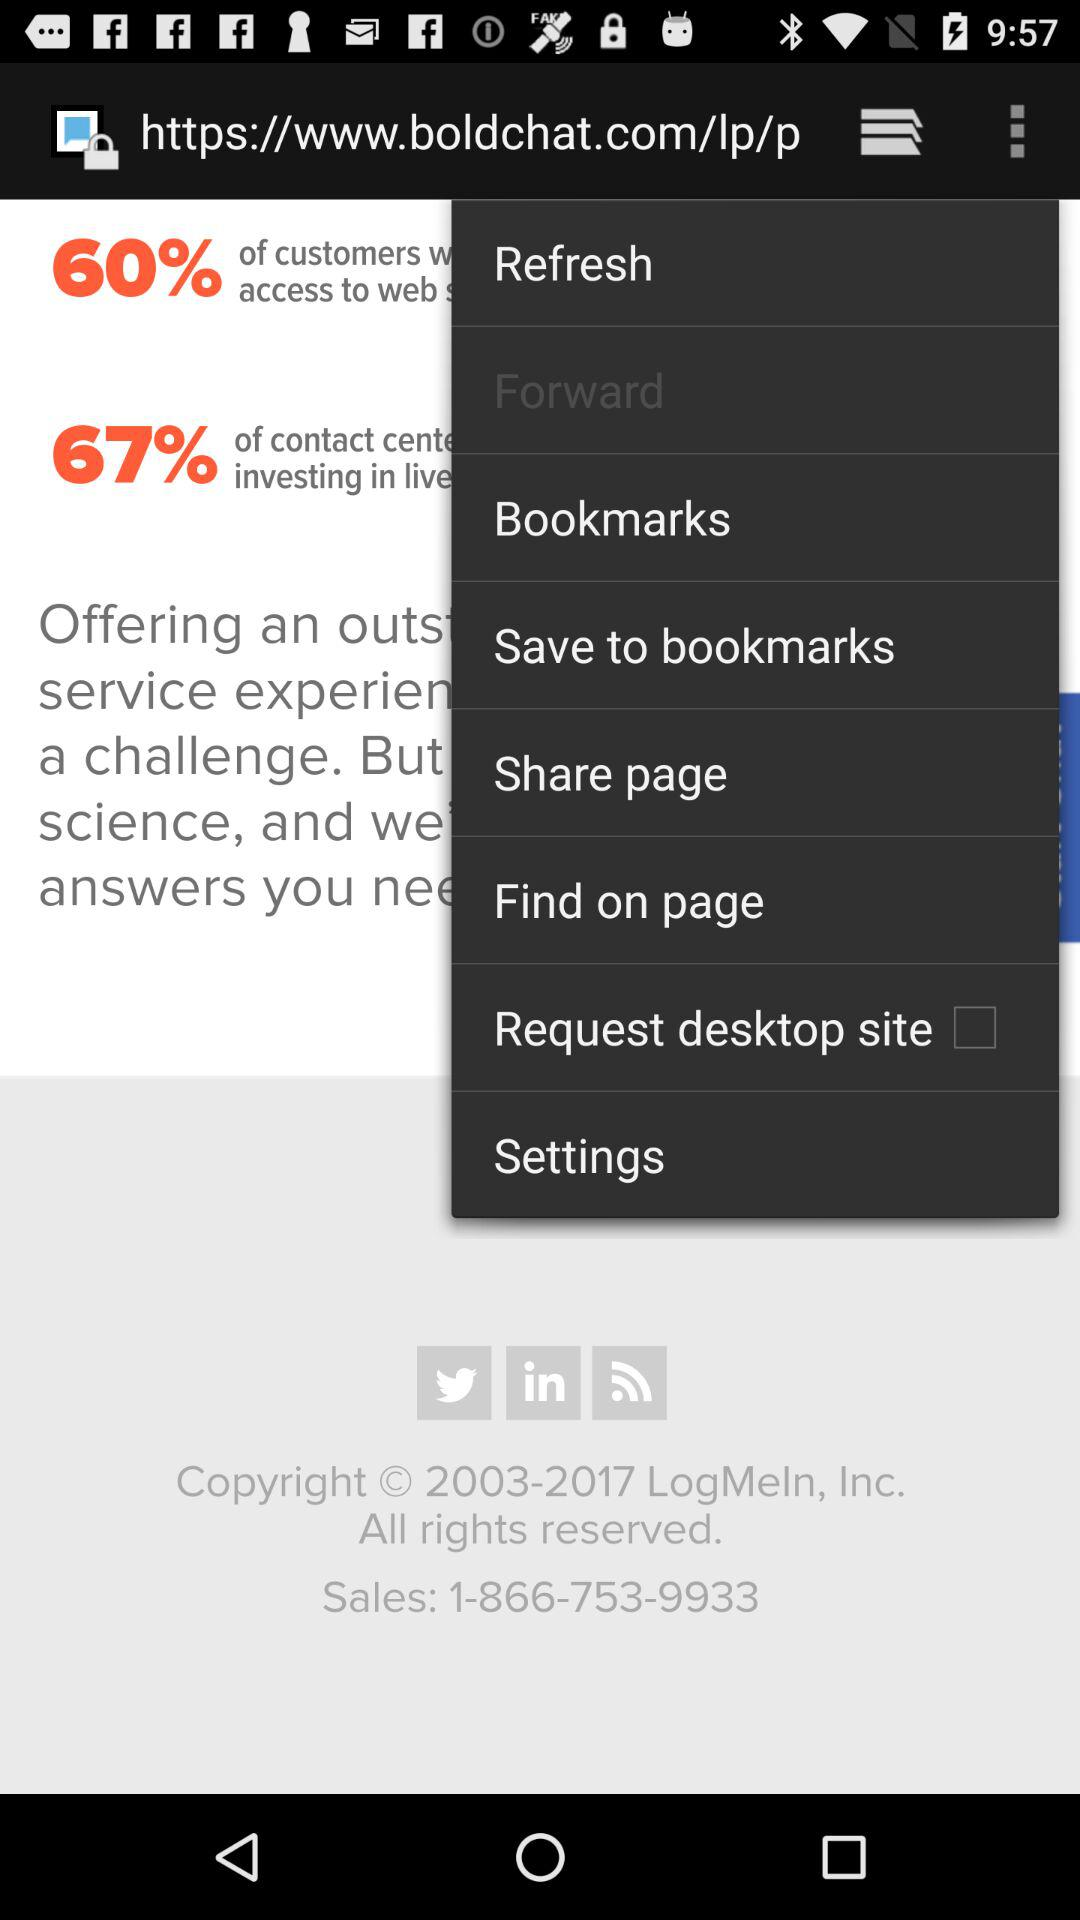What company has reserved the copyright? The rights are reserved by "LogMeIn, Inc". 